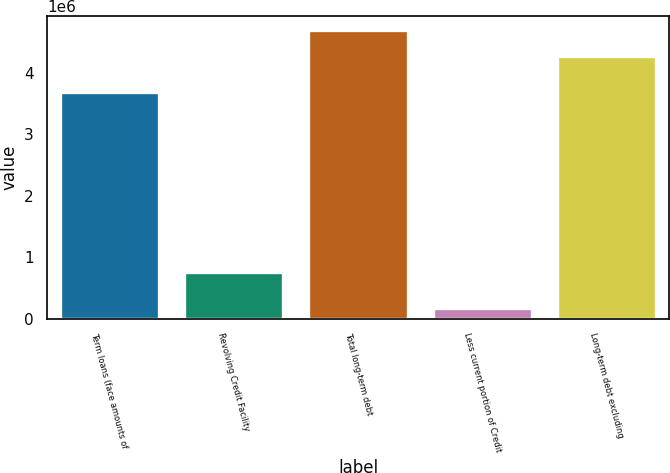Convert chart. <chart><loc_0><loc_0><loc_500><loc_500><bar_chart><fcel>Term loans (face amounts of<fcel>Revolving Credit Facility<fcel>Total long-term debt<fcel>Less current portion of Credit<fcel>Long-term debt excluding<nl><fcel>3.68258e+06<fcel>756000<fcel>4.68691e+06<fcel>177785<fcel>4.26083e+06<nl></chart> 